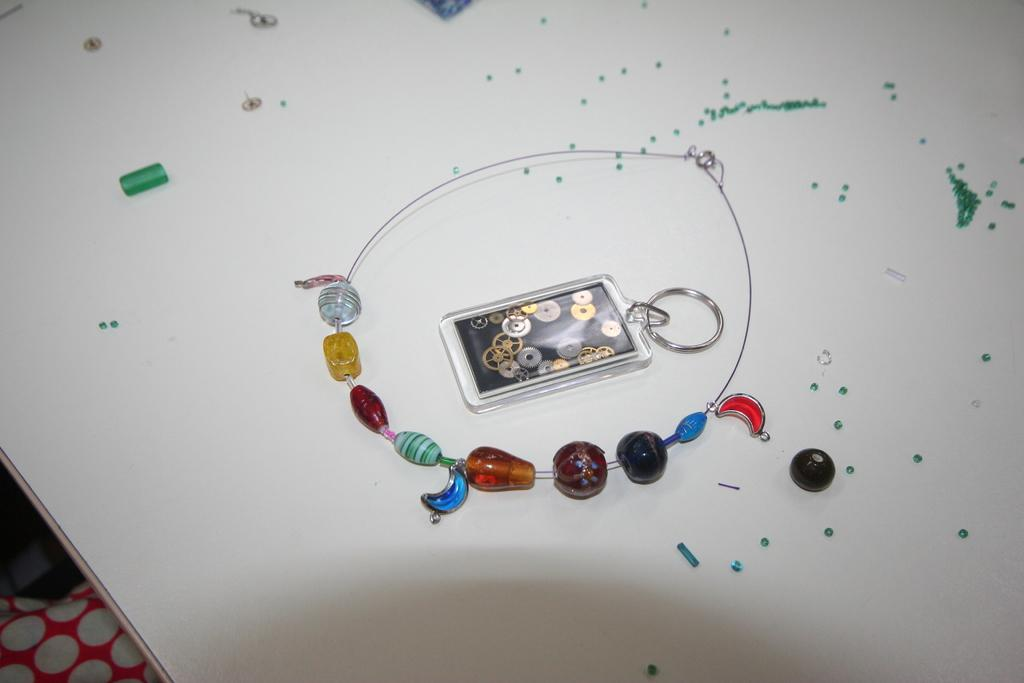What type of jewelry is visible in the image? There is a necklace of stones and beads in the image. What other accessory can be seen in the image? There is a keychain in the image. What are the other items made of in the image? There are other beads in the image. Can you describe the other tiny objects in the image? There are other tiny objects in the image, but their specific details are not mentioned in the facts. Where are these items located in the image? All these items are on a table. What is the name of the downtown street where the earth and knee are located in the image? There is no downtown street, earth, or knee present in the image. 